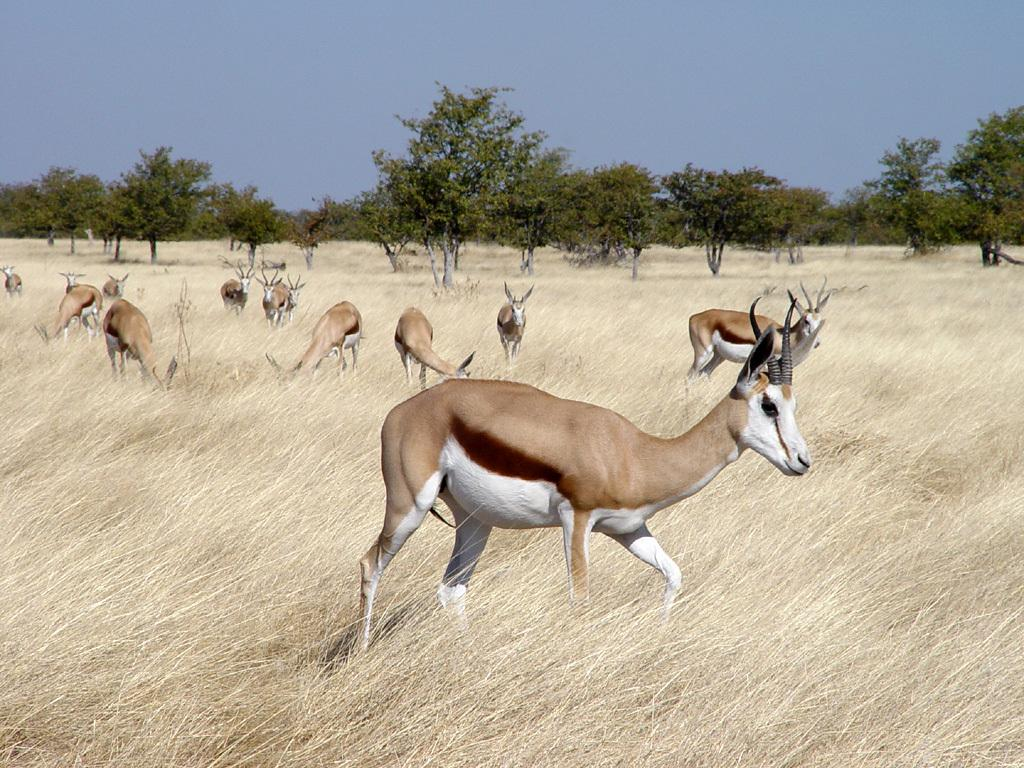What is the main subject of the image? The main subject of the image is a herd of animals. Where are the animals located in the image? The animals are standing on the grass. What can be seen in the background of the image? There are trees and the sky visible in the background of the image. What type of poison can be seen in the image? There is no poison present in the image. 